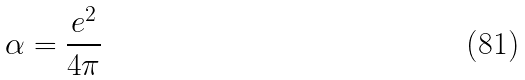<formula> <loc_0><loc_0><loc_500><loc_500>\alpha = \frac { e ^ { 2 } } { 4 \pi }</formula> 